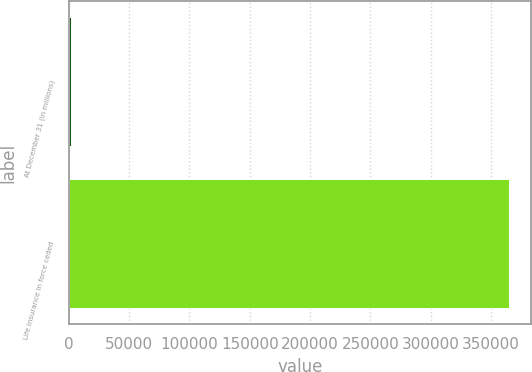<chart> <loc_0><loc_0><loc_500><loc_500><bar_chart><fcel>At December 31 (in millions)<fcel>Life Insurance in force ceded<nl><fcel>2005<fcel>365082<nl></chart> 